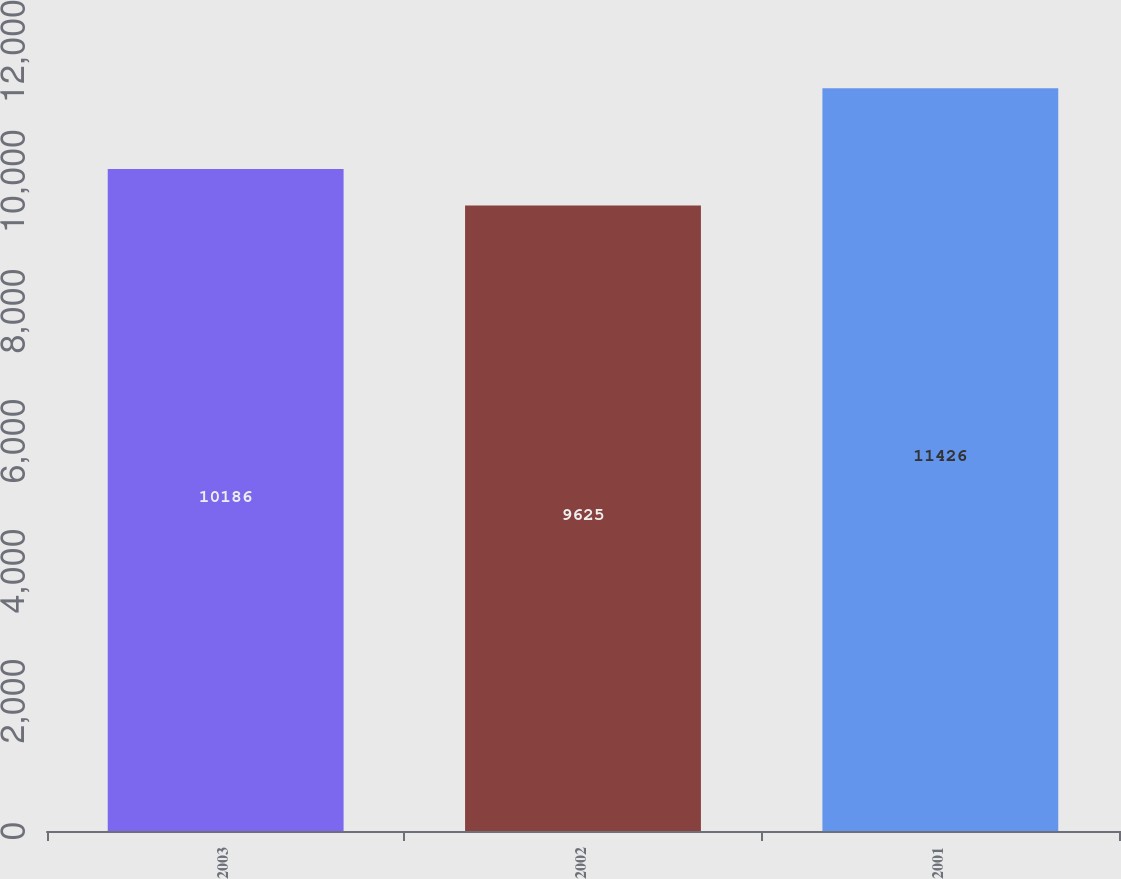Convert chart to OTSL. <chart><loc_0><loc_0><loc_500><loc_500><bar_chart><fcel>2003<fcel>2002<fcel>2001<nl><fcel>10186<fcel>9625<fcel>11426<nl></chart> 